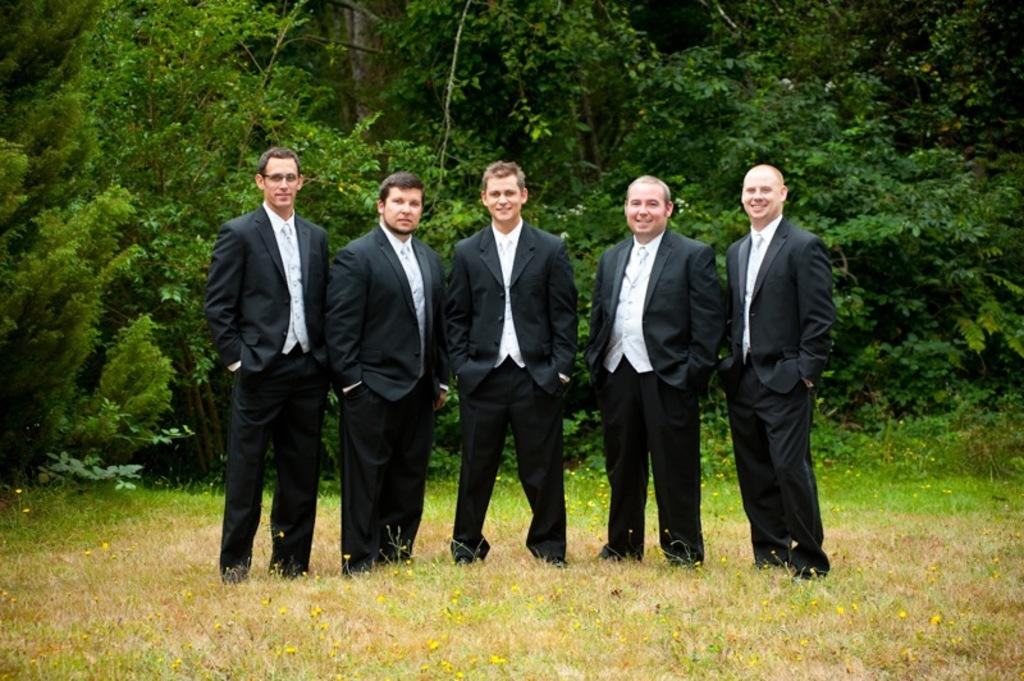How many people are standing on the grass in the image? There are five men standing on the grass in the image. What type of vegetation can be seen in the image? There are yellow flowers visible in the image. What can be seen in the background of the image? There are trees visible in the background. What shape is the trail that the men are following in the image? There is no trail visible in the image, and the men are not following any specific shape. 